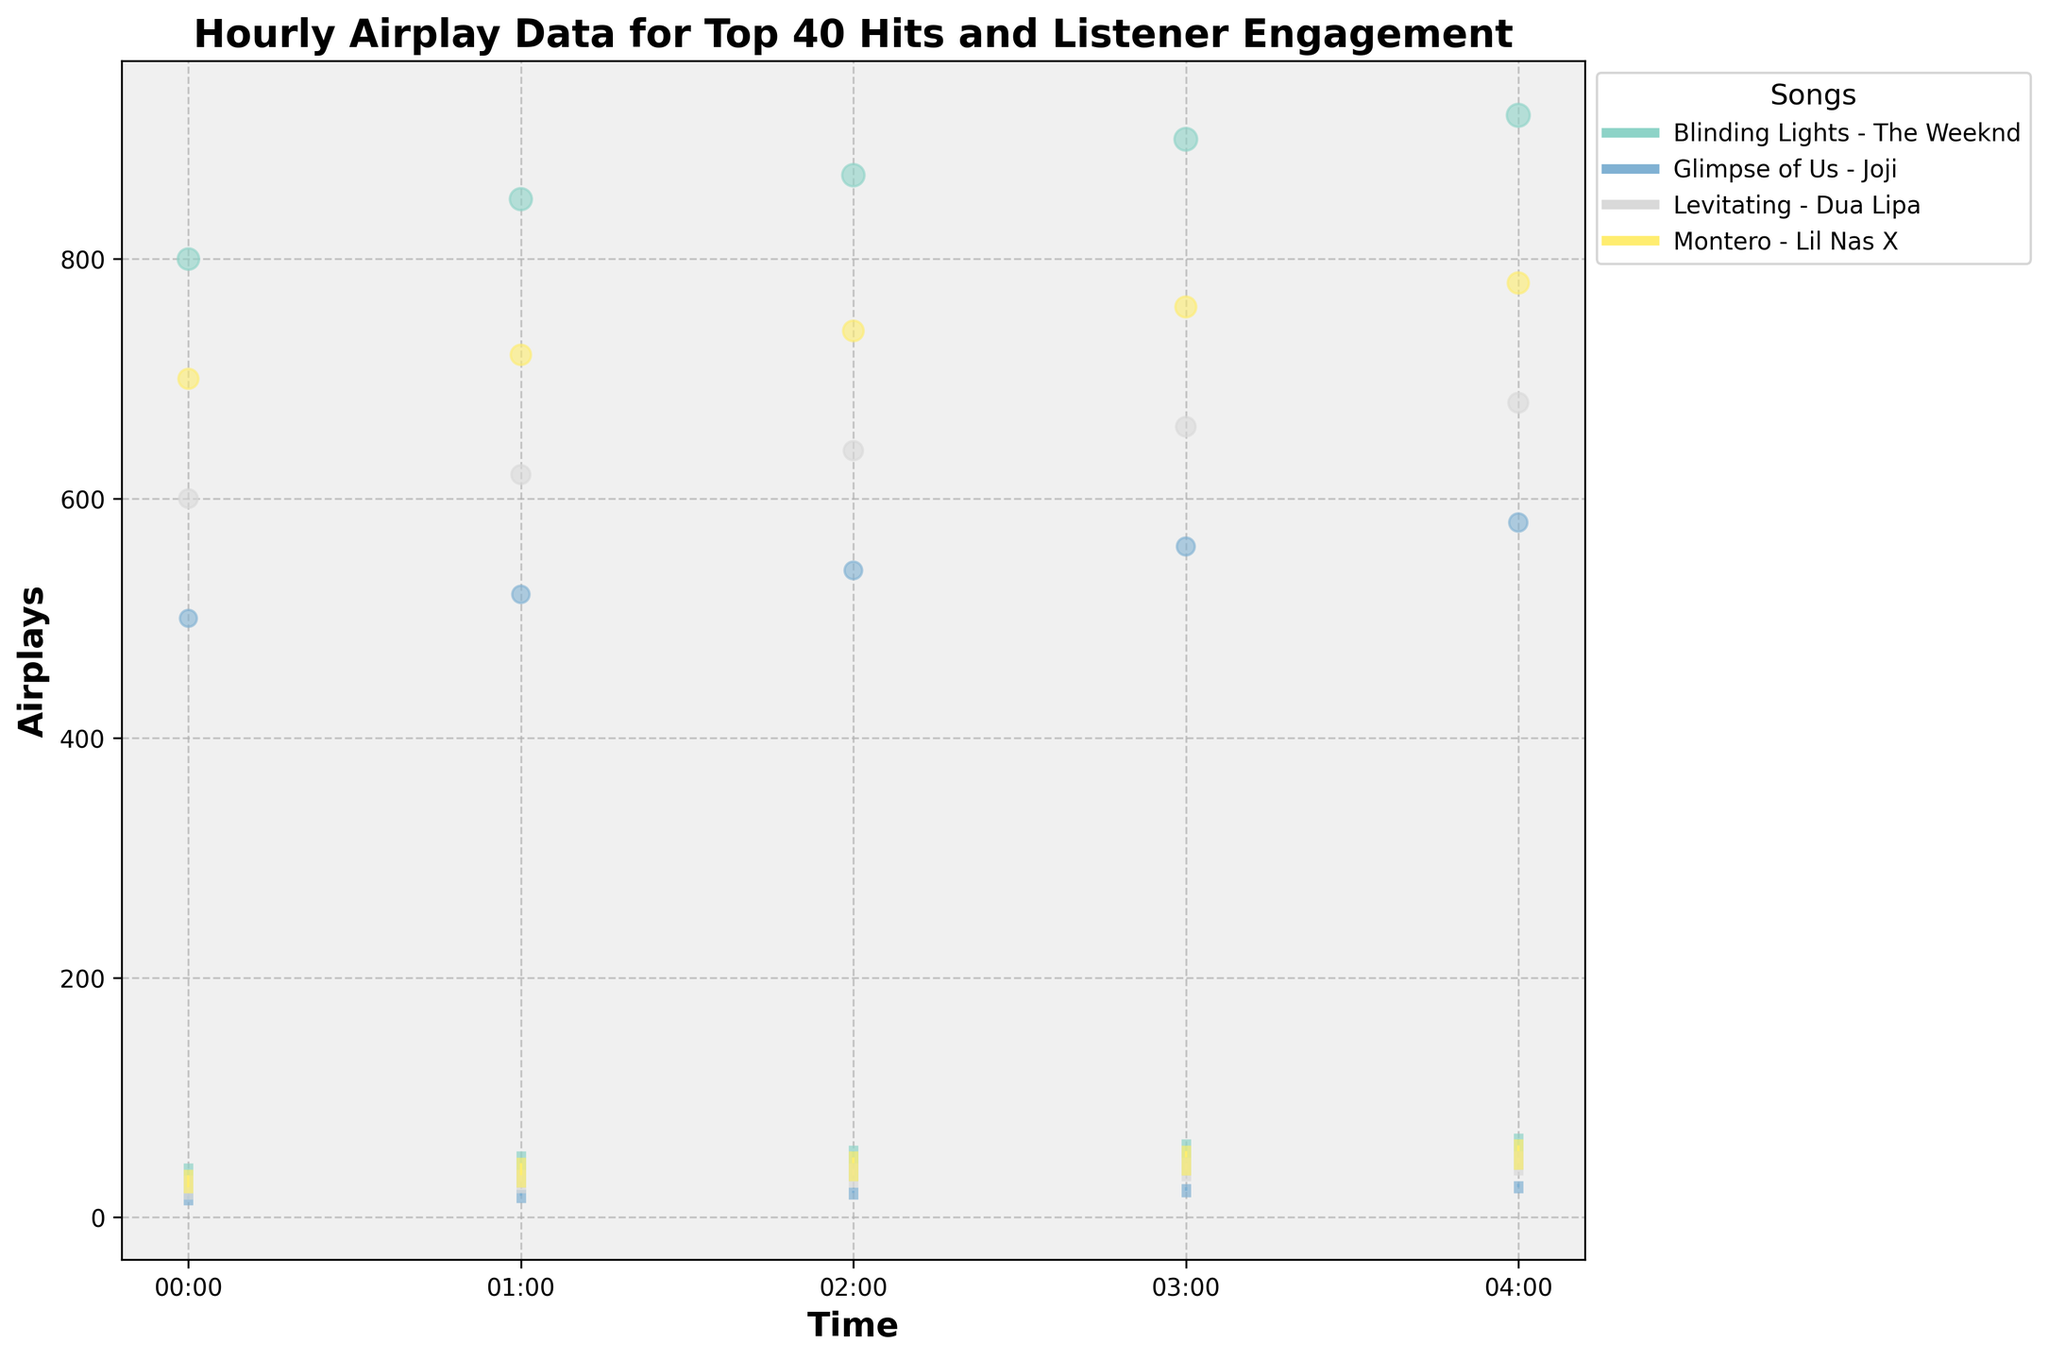What is the title of the figure? The title is located at the top of the figure and provides a summary of what the visualization represents.
Answer: Hourly Airplay Data for Top 40 Hits and Listener Engagement How many songs are represented in the figure? By identifying the number of unique entries in the legend, we can count the different songs.
Answer: Four Which song had the highest listener engagement at any hour, and what was the value? Look for the largest bubble on the chart and refer to the corresponding listener engagement value.
Answer: Blinding Lights - The Weeknd, 920 Which song shows the greatest overall increase in airplays from 00:00 to 04:00? Find the opening airplay at 00:00 and the closing airplay at 04:00 for each song, then calculate the differences. The song with the highest difference has the greatest increase.
Answer: Blinding Lights - The Weeknd What is the time interval displayed on the x-axis? Examine the x-axis labels, noting the format and range of times shown.
Answer: Hourly Compare the listener engagement for Montero - Lil Nas X and Glimpse of Us - Joji at 03:00. Which song had higher engagement? Compare the sizes of the bubbles at 03:00 for the two songs. The larger bubble corresponds to higher listener engagement.
Answer: Montero - Lil Nas X What was the range of airplays for Levitating - Dua Lipa at 01:00? Refer to the vertical line for Levitating - Dua Lipa at 01:00 and find the low and high airplay values. Calculate the range as high - low.
Answer: 20 Between 02:00 and 03:00, did any song show a decrease in airplay counts? If so, which song and by how much? Compare the closing airplays at 02:00 and 03:00 for each song to identify any decreases. Calculate by subtracting the earlier value from the later value.
Answer: None Which song maintained a consistent increase in its listener engagement values from 00:00 to 04:00? Analyze the sizes of the bubbles for each song across the specified time range to see if engagement consistently increased.
Answer: Blinding Lights - The Weeknd 